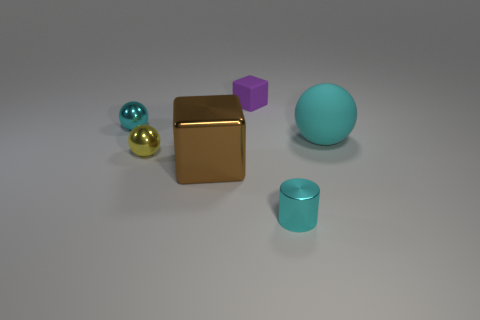Subtract all cyan spheres. How many were subtracted if there are1cyan spheres left? 1 Add 4 matte blocks. How many objects exist? 10 Subtract all blocks. How many objects are left? 4 Add 6 small purple objects. How many small purple objects are left? 7 Add 5 purple blocks. How many purple blocks exist? 6 Subtract 0 green cylinders. How many objects are left? 6 Subtract all cyan metallic balls. Subtract all metallic balls. How many objects are left? 3 